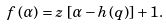Convert formula to latex. <formula><loc_0><loc_0><loc_500><loc_500>f \left ( \alpha \right ) = z \, \left [ \alpha - h \left ( q \right ) \right ] + 1 .</formula> 